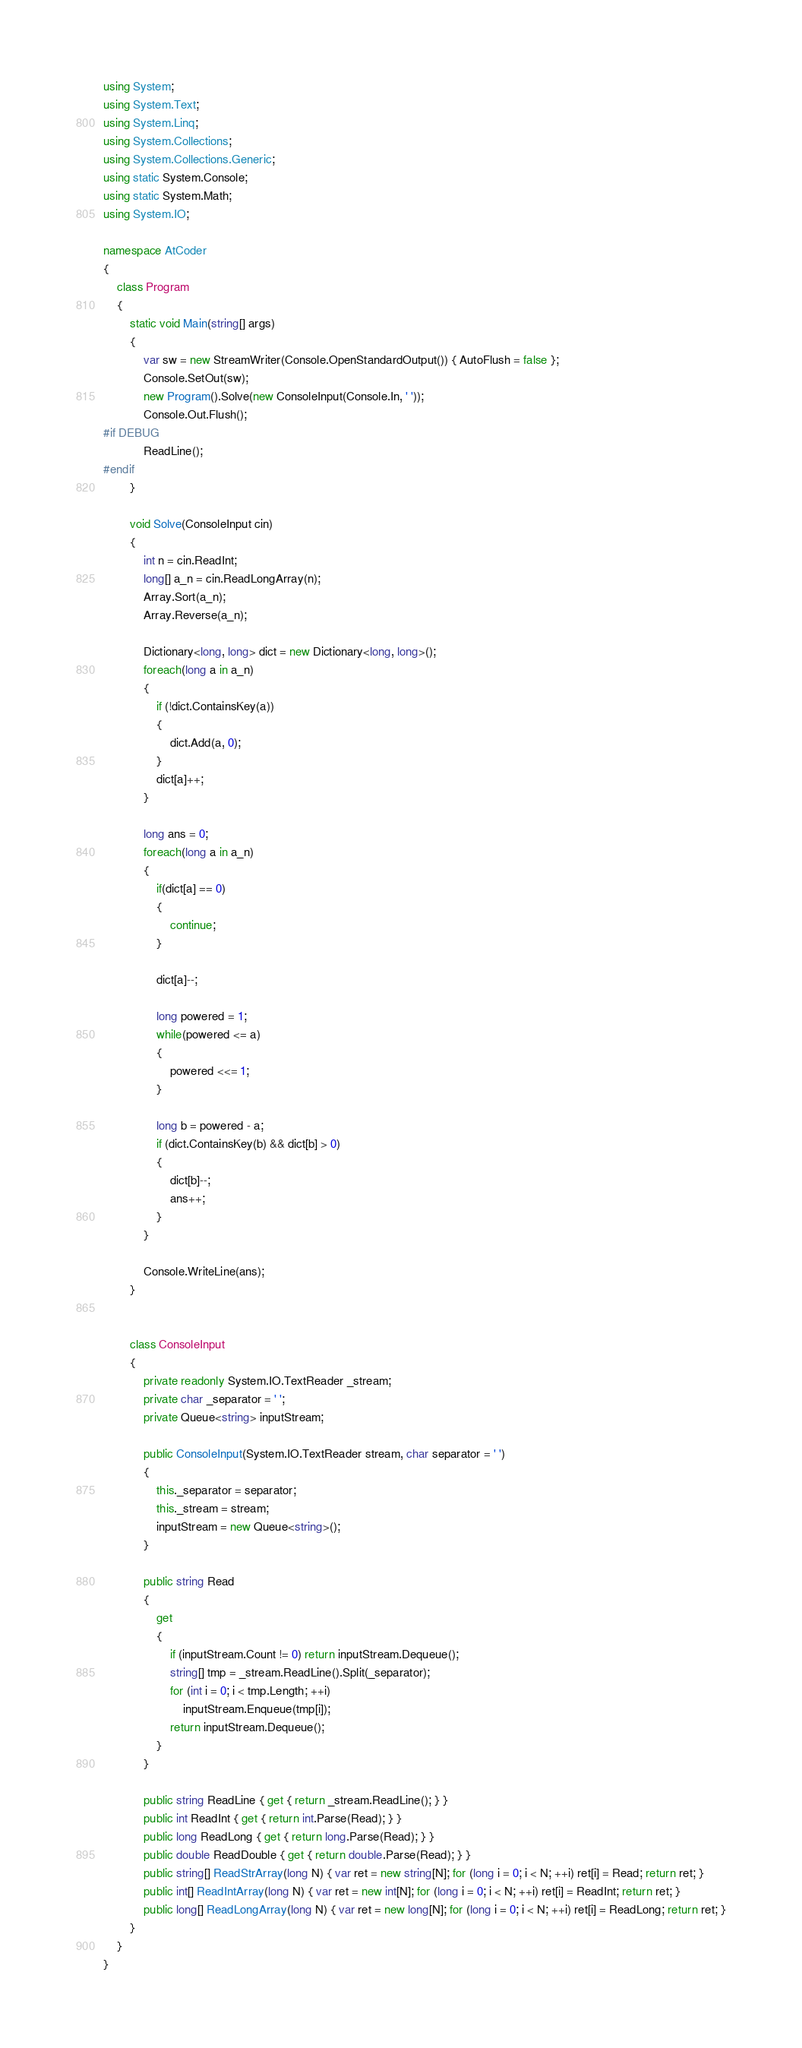Convert code to text. <code><loc_0><loc_0><loc_500><loc_500><_C#_>using System;
using System.Text;
using System.Linq;
using System.Collections;
using System.Collections.Generic;
using static System.Console;
using static System.Math;
using System.IO;

namespace AtCoder
{
    class Program
    {
        static void Main(string[] args)
        {
            var sw = new StreamWriter(Console.OpenStandardOutput()) { AutoFlush = false };
            Console.SetOut(sw);
            new Program().Solve(new ConsoleInput(Console.In, ' '));
            Console.Out.Flush();
#if DEBUG
            ReadLine();
#endif
        }

        void Solve(ConsoleInput cin)
        {
            int n = cin.ReadInt;
            long[] a_n = cin.ReadLongArray(n);
            Array.Sort(a_n);
            Array.Reverse(a_n);

            Dictionary<long, long> dict = new Dictionary<long, long>();
            foreach(long a in a_n)
            {
                if (!dict.ContainsKey(a))
                {
                    dict.Add(a, 0);
                }
                dict[a]++;
            }

            long ans = 0;
            foreach(long a in a_n)
            {
                if(dict[a] == 0)
                {
                    continue;
                }

                dict[a]--;

                long powered = 1;
                while(powered <= a)
                {
                    powered <<= 1;
                }

                long b = powered - a;
                if (dict.ContainsKey(b) && dict[b] > 0)
                {
                    dict[b]--;
                    ans++;
                }
            }

            Console.WriteLine(ans);
        }


        class ConsoleInput
        {
            private readonly System.IO.TextReader _stream;
            private char _separator = ' ';
            private Queue<string> inputStream;

            public ConsoleInput(System.IO.TextReader stream, char separator = ' ')
            {
                this._separator = separator;
                this._stream = stream;
                inputStream = new Queue<string>();
            }

            public string Read
            {
                get
                {
                    if (inputStream.Count != 0) return inputStream.Dequeue();
                    string[] tmp = _stream.ReadLine().Split(_separator);
                    for (int i = 0; i < tmp.Length; ++i)
                        inputStream.Enqueue(tmp[i]);
                    return inputStream.Dequeue();
                }
            }

            public string ReadLine { get { return _stream.ReadLine(); } }
            public int ReadInt { get { return int.Parse(Read); } }
            public long ReadLong { get { return long.Parse(Read); } }
            public double ReadDouble { get { return double.Parse(Read); } }
            public string[] ReadStrArray(long N) { var ret = new string[N]; for (long i = 0; i < N; ++i) ret[i] = Read; return ret; }
            public int[] ReadIntArray(long N) { var ret = new int[N]; for (long i = 0; i < N; ++i) ret[i] = ReadInt; return ret; }
            public long[] ReadLongArray(long N) { var ret = new long[N]; for (long i = 0; i < N; ++i) ret[i] = ReadLong; return ret; }
        }
    }
}</code> 